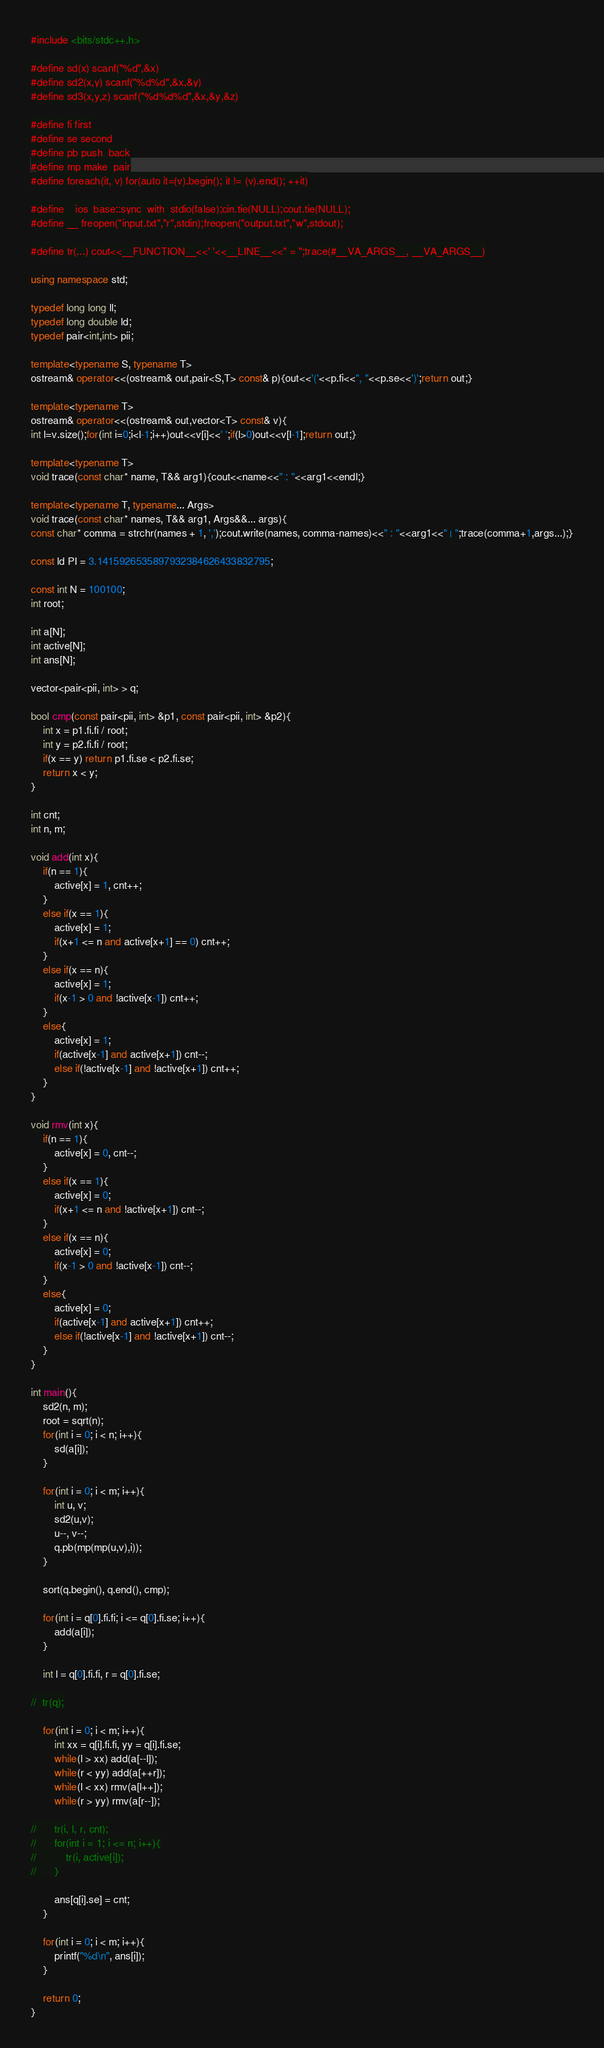<code> <loc_0><loc_0><loc_500><loc_500><_C++_>#include <bits/stdc++.h>

#define sd(x) scanf("%d",&x)
#define sd2(x,y) scanf("%d%d",&x,&y)
#define sd3(x,y,z) scanf("%d%d%d",&x,&y,&z)

#define fi first
#define se second
#define pb push_back
#define mp make_pair
#define foreach(it, v) for(auto it=(v).begin(); it != (v).end(); ++it)

#define _ ios_base::sync_with_stdio(false);cin.tie(NULL);cout.tie(NULL);
#define __ freopen("input.txt","r",stdin);freopen("output.txt","w",stdout);

#define tr(...) cout<<__FUNCTION__<<' '<<__LINE__<<" = ";trace(#__VA_ARGS__, __VA_ARGS__)

using namespace std;

typedef long long ll;
typedef long double ld;
typedef pair<int,int> pii;

template<typename S, typename T> 
ostream& operator<<(ostream& out,pair<S,T> const& p){out<<'('<<p.fi<<", "<<p.se<<')';return out;}

template<typename T>
ostream& operator<<(ostream& out,vector<T> const& v){
int l=v.size();for(int i=0;i<l-1;i++)out<<v[i]<<' ';if(l>0)out<<v[l-1];return out;}

template<typename T>
void trace(const char* name, T&& arg1){cout<<name<<" : "<<arg1<<endl;}

template<typename T, typename... Args>
void trace(const char* names, T&& arg1, Args&&... args){
const char* comma = strchr(names + 1, ',');cout.write(names, comma-names)<<" : "<<arg1<<" | ";trace(comma+1,args...);}

const ld PI = 3.1415926535897932384626433832795;

const int N = 100100;
int root;

int a[N];
int active[N];
int ans[N];

vector<pair<pii, int> > q;

bool cmp(const pair<pii, int> &p1, const pair<pii, int> &p2){
	int x = p1.fi.fi / root;
	int y = p2.fi.fi / root;
	if(x == y) return p1.fi.se < p2.fi.se;
	return x < y;
}

int cnt;
int n, m;

void add(int x){
	if(n == 1){
		active[x] = 1, cnt++;
	}
	else if(x == 1){
		active[x] = 1;
		if(x+1 <= n and active[x+1] == 0) cnt++;
	}
	else if(x == n){
		active[x] = 1;
		if(x-1 > 0 and !active[x-1]) cnt++;
	}
	else{
		active[x] = 1;
		if(active[x-1] and active[x+1]) cnt--;
		else if(!active[x-1] and !active[x+1]) cnt++;
	}
}

void rmv(int x){
	if(n == 1){
		active[x] = 0, cnt--;
	}
	else if(x == 1){
		active[x] = 0;
		if(x+1 <= n and !active[x+1]) cnt--;
	}
	else if(x == n){
		active[x] = 0;
		if(x-1 > 0 and !active[x-1]) cnt--;
	}
	else{
		active[x] = 0;
		if(active[x-1] and active[x+1]) cnt++;
		else if(!active[x-1] and !active[x+1]) cnt--;
	}
}

int main(){
	sd2(n, m);
	root = sqrt(n);
	for(int i = 0; i < n; i++){
		sd(a[i]);
	}
	
	for(int i = 0; i < m; i++){
		int u, v;
		sd2(u,v);
		u--, v--;
		q.pb(mp(mp(u,v),i));
	}
	
	sort(q.begin(), q.end(), cmp);
	
	for(int i = q[0].fi.fi; i <= q[0].fi.se; i++){
		add(a[i]);
	}
	
	int l = q[0].fi.fi, r = q[0].fi.se;
	
//	tr(q);
	
	for(int i = 0; i < m; i++){
		int xx = q[i].fi.fi, yy = q[i].fi.se;
		while(l > xx) add(a[--l]);
		while(r < yy) add(a[++r]);
		while(l < xx) rmv(a[l++]);
		while(r > yy) rmv(a[r--]);
		
//		tr(i, l, r, cnt);
//		for(int i = 1; i <= n; i++){
//			tr(i, active[i]);
//		}
		
		ans[q[i].se] = cnt;
	}
	
	for(int i = 0; i < m; i++){
		printf("%d\n", ans[i]);
	}
		
	return 0;
}
</code> 